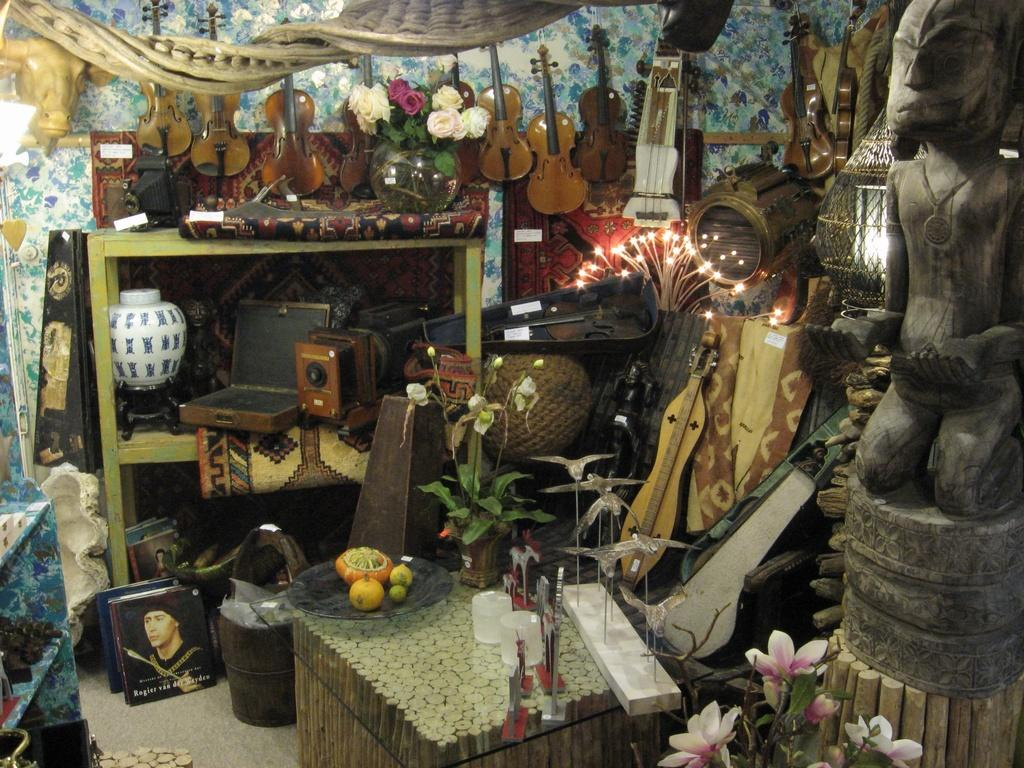What type of musical instruments are on the wall in the image? There are guitars on the wall in the image. What other musical instruments can be seen in the image? There are musical instruments in the image, but the specific types are not mentioned. What is located on the right side of the image? There is a statue on the right side of the image. What type of waste is being recycled in the image? There is no waste or recycling depicted in the image. How many stalks of celery are visible in the image? There is no celery present in the image. 